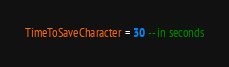<code> <loc_0><loc_0><loc_500><loc_500><_Lua_>TimeToSaveCharacter = 30 -- in seconds</code> 